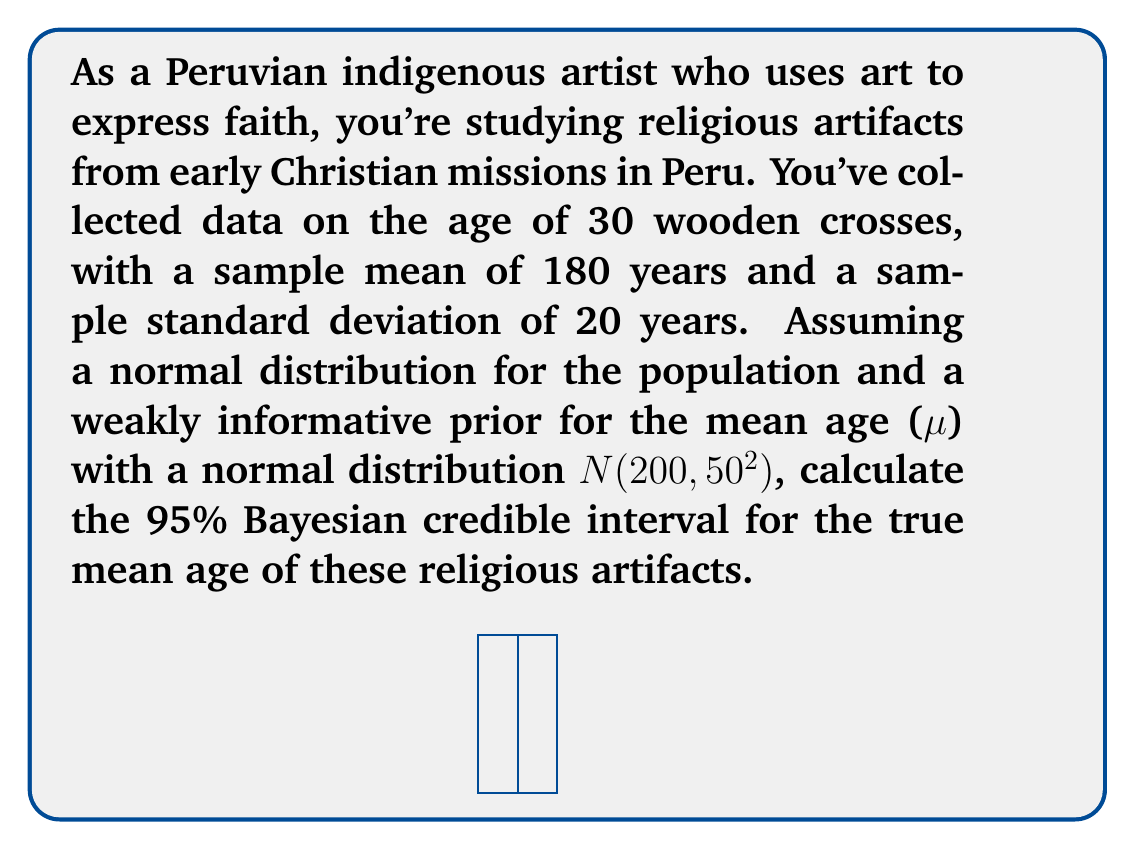Could you help me with this problem? Let's approach this step-by-step using Bayesian analysis:

1) First, we need to calculate the posterior distribution for μ. In Bayesian statistics, the posterior is proportional to the prior times the likelihood.

2) Our prior is N(200, 50²) and our likelihood is based on the sample data.

3) The posterior distribution for μ will also be normal, with parameters:

   $$\mu_{posterior} = \frac{\frac{\mu_{prior}}{\sigma_{prior}^2} + \frac{n\bar{x}}{\sigma^2}}{\frac{1}{\sigma_{prior}^2} + \frac{n}{\sigma^2}}$$

   $$\sigma_{posterior}^2 = \frac{1}{\frac{1}{\sigma_{prior}^2} + \frac{n}{\sigma^2}}$$

4) Let's plug in our values:
   $\mu_{prior} = 200$, $\sigma_{prior} = 50$, $n = 30$, $\bar{x} = 180$, $\sigma = 20$

5) Calculate $\sigma_{posterior}^2$:
   $$\sigma_{posterior}^2 = \frac{1}{\frac{1}{50^2} + \frac{30}{20^2}} \approx 13.22$$

6) Calculate $\mu_{posterior}$:
   $$\mu_{posterior} = \frac{\frac{200}{50^2} + \frac{30 \cdot 180}{20^2}}{\frac{1}{50^2} + \frac{30}{20^2}} \approx 180.79$$

7) The 95% credible interval is given by:
   $$[\mu_{posterior} - 1.96\sigma_{posterior}, \mu_{posterior} + 1.96\sigma_{posterior}]$$

8) Plugging in our values:
   $$[180.79 - 1.96\sqrt{13.22}, 180.79 + 1.96\sqrt{13.22}]$$
   $$[173.67, 187.91]$$

Therefore, the 95% Bayesian credible interval for the true mean age of the religious artifacts is approximately [173.67, 187.91] years.
Answer: [173.67, 187.91] years 